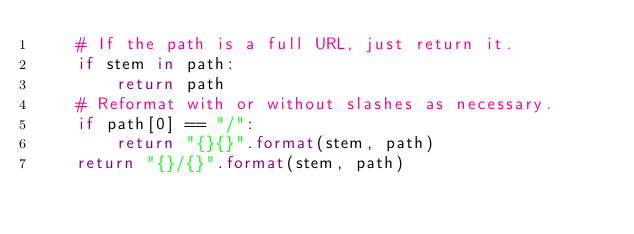<code> <loc_0><loc_0><loc_500><loc_500><_Python_>    # If the path is a full URL, just return it.
    if stem in path:
        return path
    # Reformat with or without slashes as necessary.
    if path[0] == "/":
        return "{}{}".format(stem, path)
    return "{}/{}".format(stem, path)
</code> 